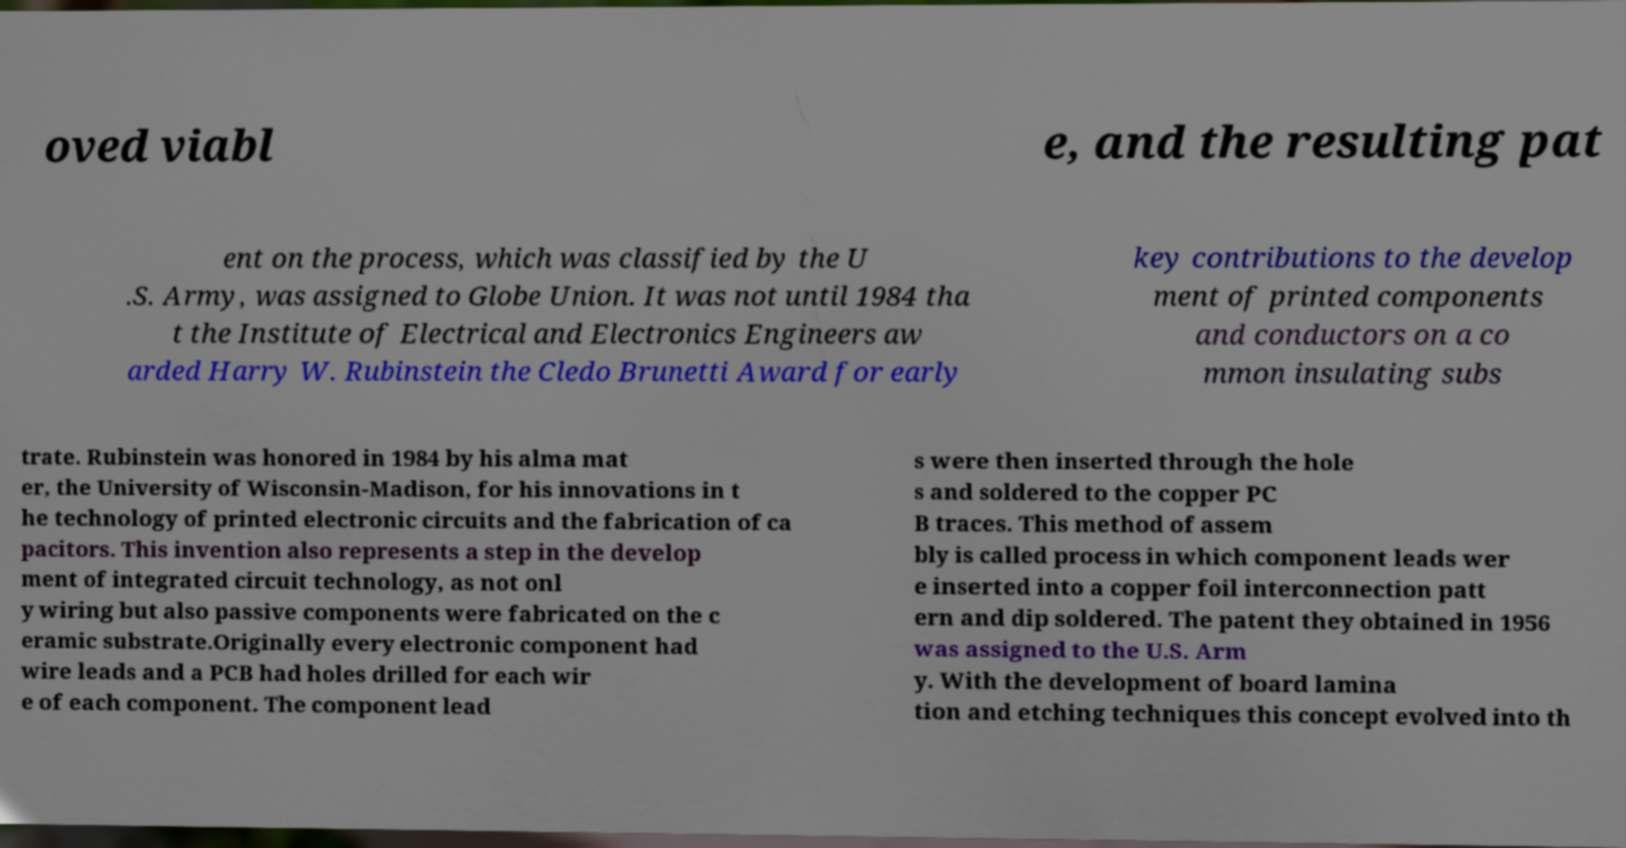Could you assist in decoding the text presented in this image and type it out clearly? oved viabl e, and the resulting pat ent on the process, which was classified by the U .S. Army, was assigned to Globe Union. It was not until 1984 tha t the Institute of Electrical and Electronics Engineers aw arded Harry W. Rubinstein the Cledo Brunetti Award for early key contributions to the develop ment of printed components and conductors on a co mmon insulating subs trate. Rubinstein was honored in 1984 by his alma mat er, the University of Wisconsin-Madison, for his innovations in t he technology of printed electronic circuits and the fabrication of ca pacitors. This invention also represents a step in the develop ment of integrated circuit technology, as not onl y wiring but also passive components were fabricated on the c eramic substrate.Originally every electronic component had wire leads and a PCB had holes drilled for each wir e of each component. The component lead s were then inserted through the hole s and soldered to the copper PC B traces. This method of assem bly is called process in which component leads wer e inserted into a copper foil interconnection patt ern and dip soldered. The patent they obtained in 1956 was assigned to the U.S. Arm y. With the development of board lamina tion and etching techniques this concept evolved into th 